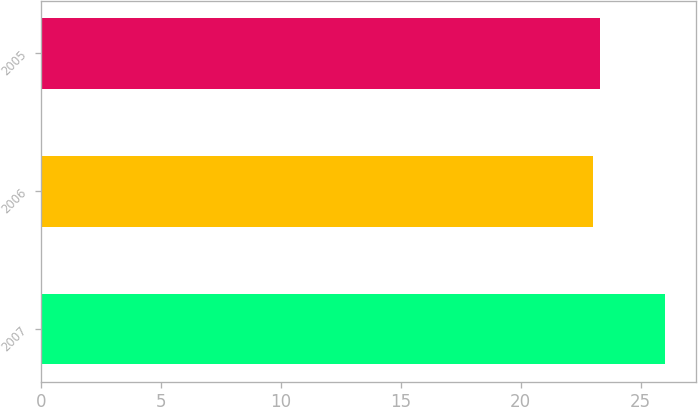<chart> <loc_0><loc_0><loc_500><loc_500><bar_chart><fcel>2007<fcel>2006<fcel>2005<nl><fcel>26<fcel>23<fcel>23.3<nl></chart> 